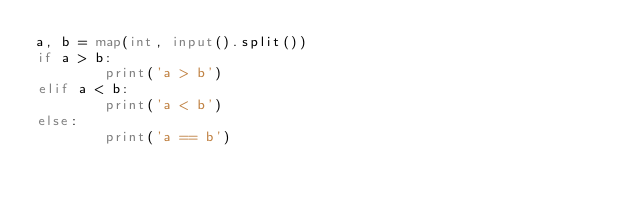Convert code to text. <code><loc_0><loc_0><loc_500><loc_500><_Python_>a, b = map(int, input().split())
if a > b:
        print('a > b')
elif a < b:
        print('a < b')
else:
        print('a == b')
</code> 